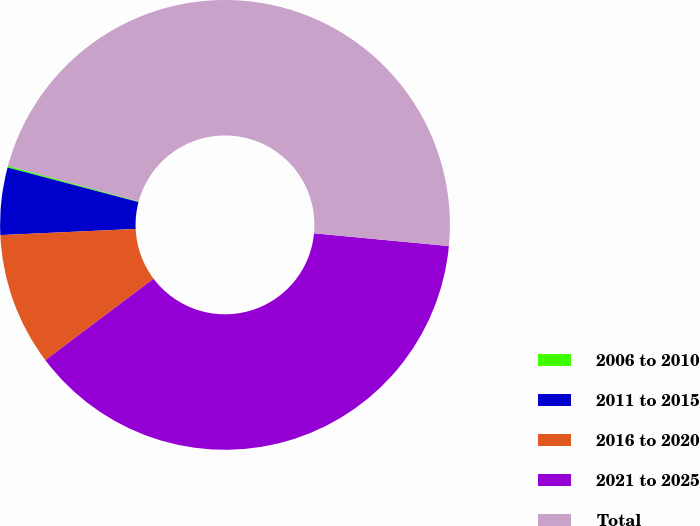Convert chart. <chart><loc_0><loc_0><loc_500><loc_500><pie_chart><fcel>2006 to 2010<fcel>2011 to 2015<fcel>2016 to 2020<fcel>2021 to 2025<fcel>Total<nl><fcel>0.12%<fcel>4.83%<fcel>9.55%<fcel>38.23%<fcel>47.28%<nl></chart> 